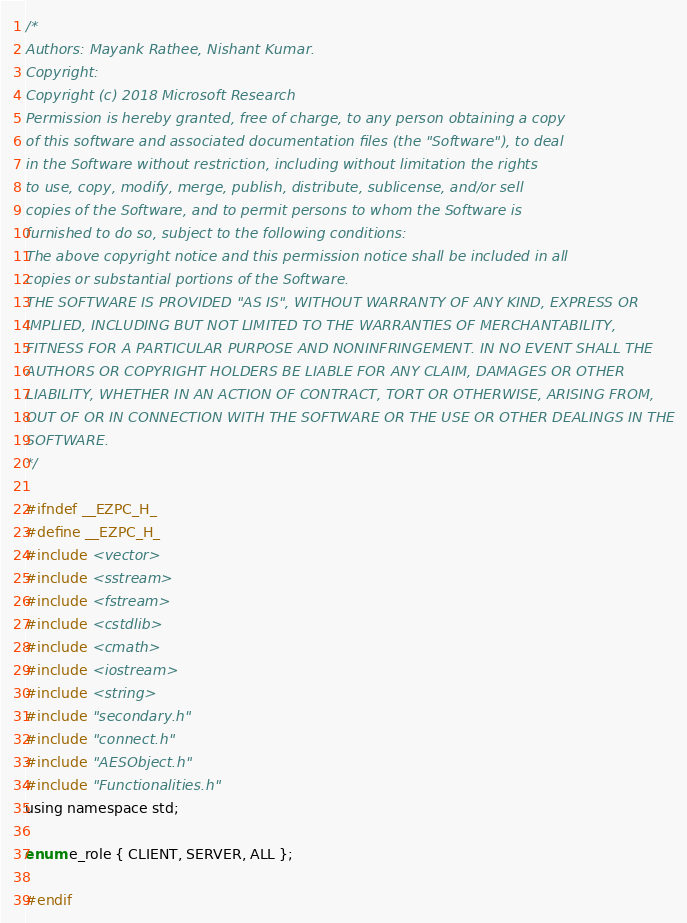Convert code to text. <code><loc_0><loc_0><loc_500><loc_500><_C_>/*
Authors: Mayank Rathee, Nishant Kumar.
Copyright:
Copyright (c) 2018 Microsoft Research
Permission is hereby granted, free of charge, to any person obtaining a copy
of this software and associated documentation files (the "Software"), to deal
in the Software without restriction, including without limitation the rights
to use, copy, modify, merge, publish, distribute, sublicense, and/or sell
copies of the Software, and to permit persons to whom the Software is
furnished to do so, subject to the following conditions:
The above copyright notice and this permission notice shall be included in all
copies or substantial portions of the Software.
THE SOFTWARE IS PROVIDED "AS IS", WITHOUT WARRANTY OF ANY KIND, EXPRESS OR
IMPLIED, INCLUDING BUT NOT LIMITED TO THE WARRANTIES OF MERCHANTABILITY,
FITNESS FOR A PARTICULAR PURPOSE AND NONINFRINGEMENT. IN NO EVENT SHALL THE
AUTHORS OR COPYRIGHT HOLDERS BE LIABLE FOR ANY CLAIM, DAMAGES OR OTHER
LIABILITY, WHETHER IN AN ACTION OF CONTRACT, TORT OR OTHERWISE, ARISING FROM,
OUT OF OR IN CONNECTION WITH THE SOFTWARE OR THE USE OR OTHER DEALINGS IN THE
SOFTWARE.
*/

#ifndef __EZPC_H_
#define __EZPC_H_
#include <vector>
#include <sstream>
#include <fstream>
#include <cstdlib>
#include <cmath>
#include <iostream>
#include <string>
#include "secondary.h"
#include "connect.h"
#include "AESObject.h"
#include "Functionalities.h"
using namespace std;

enum e_role { CLIENT, SERVER, ALL };

#endif
</code> 